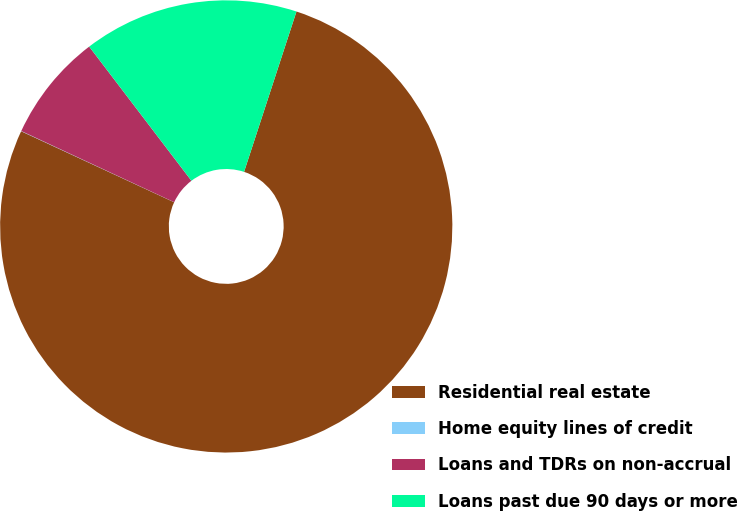Convert chart to OTSL. <chart><loc_0><loc_0><loc_500><loc_500><pie_chart><fcel>Residential real estate<fcel>Home equity lines of credit<fcel>Loans and TDRs on non-accrual<fcel>Loans past due 90 days or more<nl><fcel>76.89%<fcel>0.02%<fcel>7.7%<fcel>15.39%<nl></chart> 